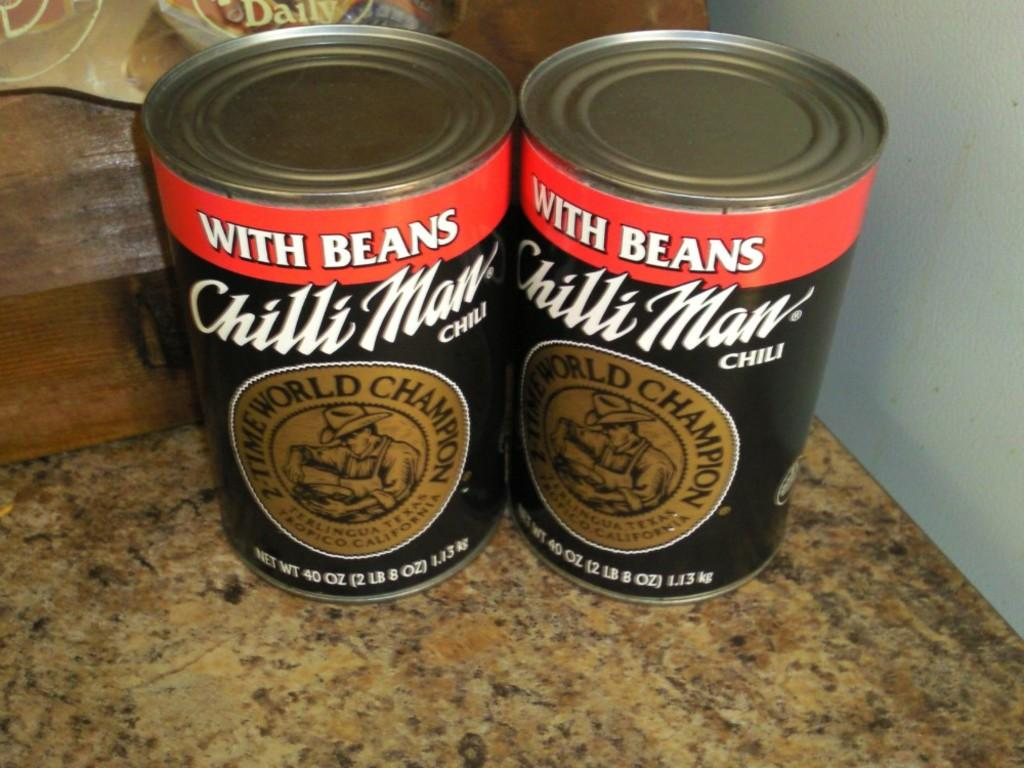Provide a one-sentence caption for the provided image. Two cans of chili with beans made by Chili Man, a two time world champion company, are sitting on a surface. 